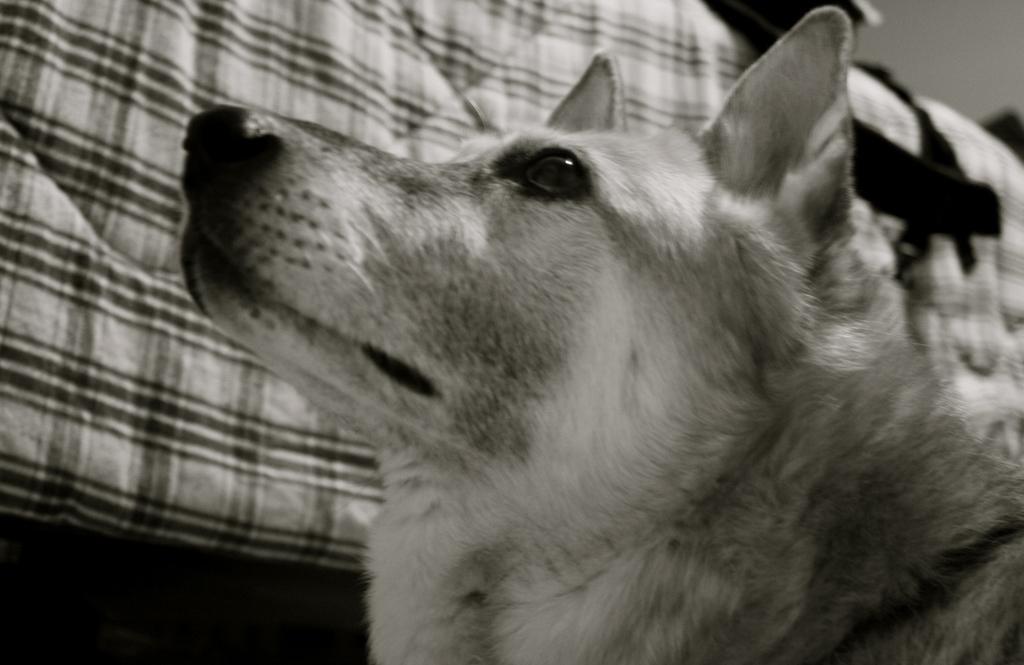Please provide a concise description of this image. This is black and white image, in this image there is a dog, in the background there is a cloth. 